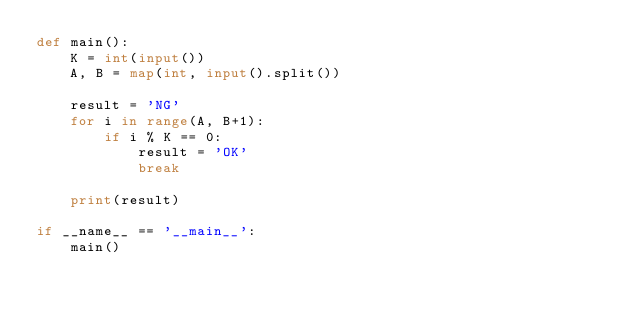Convert code to text. <code><loc_0><loc_0><loc_500><loc_500><_Python_>def main():
    K = int(input())
    A, B = map(int, input().split())

    result = 'NG'
    for i in range(A, B+1):
        if i % K == 0:
            result = 'OK'
            break
    
    print(result)

if __name__ == '__main__':
    main()</code> 